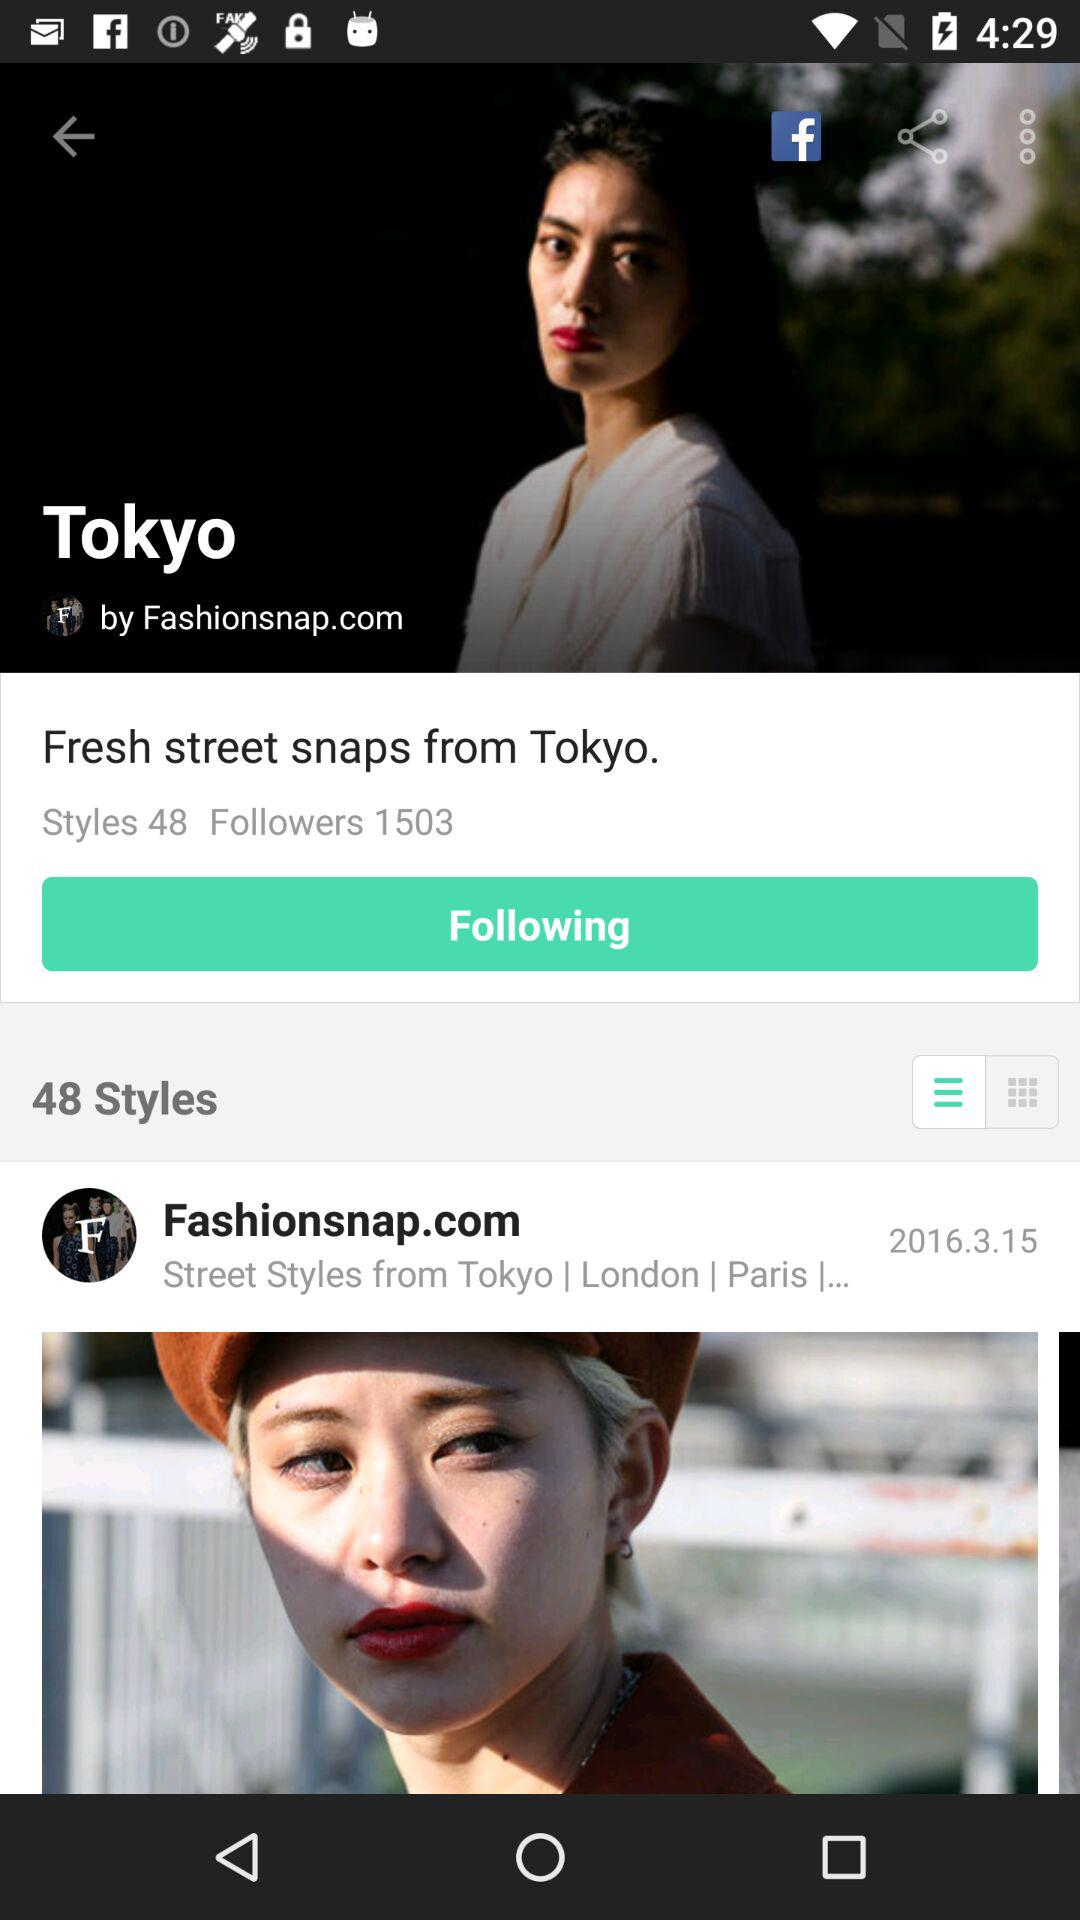What is the location for the Fresh Street Snaps? The location for the Fresh Street Snaps is Tokyo. 